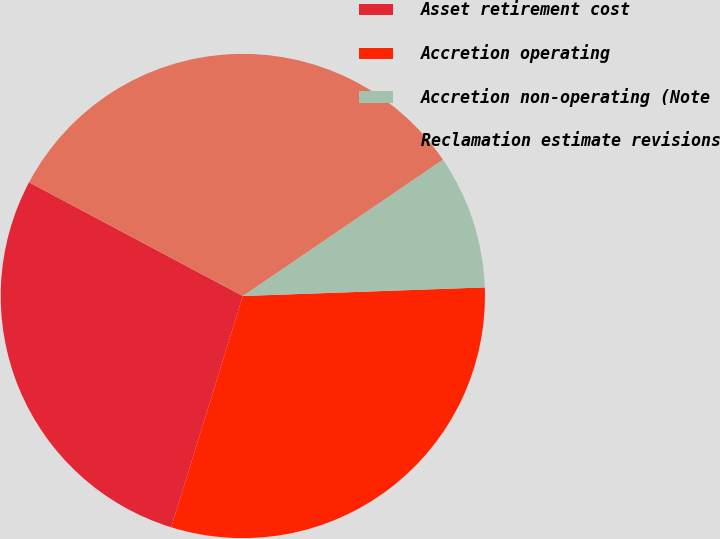Convert chart to OTSL. <chart><loc_0><loc_0><loc_500><loc_500><pie_chart><fcel>Asset retirement cost<fcel>Accretion operating<fcel>Accretion non-operating (Note<fcel>Reclamation estimate revisions<nl><fcel>28.0%<fcel>30.35%<fcel>8.96%<fcel>32.7%<nl></chart> 